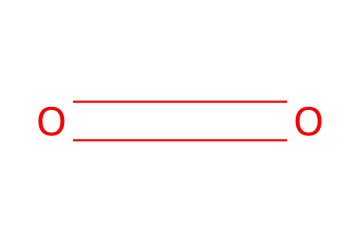What is the chemical name of the structure? The chemical represented by the SMILES notation "O=O" is diatomic oxygen, commonly referred to as oxygen gas.
Answer: oxygen How many oxygen atoms are present in the structure? The SMILES notation "O=O" indicates two oxygen atoms are connected by a double bond, showing there are two atoms in total.
Answer: 2 What type of bond is present in this structure? The structure "O=O" shows a double bond between the two oxygen atoms, which is characteristic of oxygen gas and indicates the type of chemical bond present.
Answer: double bond What is the oxidation state of oxygen in this molecule? In the case of diatomic oxygen gas, each oxygen atom has an oxidation state of 0, as it is in its elemental form and not combined with any other element.
Answer: 0 What role does this molecule play in combustion reactions? Oxygen is known as an oxidizer and is crucial in combustion reactions, as it reacts with fuel to support the burning process.
Answer: oxidizer How does the molecular arrangement affect its reactivity? The diatomic arrangement of oxygen allows it to readily bond with various elements when in its gaseous state, increasing its oxidation capability during reactions.
Answer: reactivity 